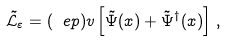<formula> <loc_0><loc_0><loc_500><loc_500>\tilde { \mathcal { L } } _ { \varepsilon } = ( \ e p ) v \left [ \tilde { \Psi } ( x ) + \tilde { \Psi } ^ { \dag } ( x ) \right ] \, ,</formula> 